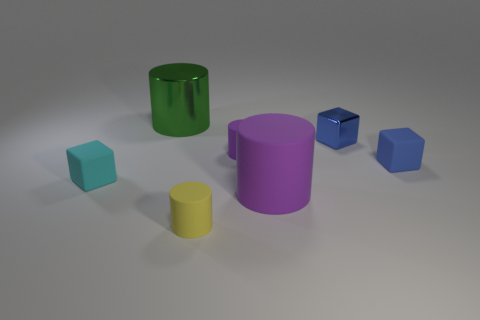Subtract all rubber cylinders. How many cylinders are left? 1 Subtract all purple balls. How many blue blocks are left? 2 Add 2 tiny objects. How many objects exist? 9 Subtract all green cylinders. How many cylinders are left? 3 Subtract 2 cylinders. How many cylinders are left? 2 Subtract 0 green cubes. How many objects are left? 7 Subtract all blocks. How many objects are left? 4 Subtract all yellow cylinders. Subtract all brown spheres. How many cylinders are left? 3 Subtract all big purple rubber balls. Subtract all green shiny cylinders. How many objects are left? 6 Add 5 blue objects. How many blue objects are left? 7 